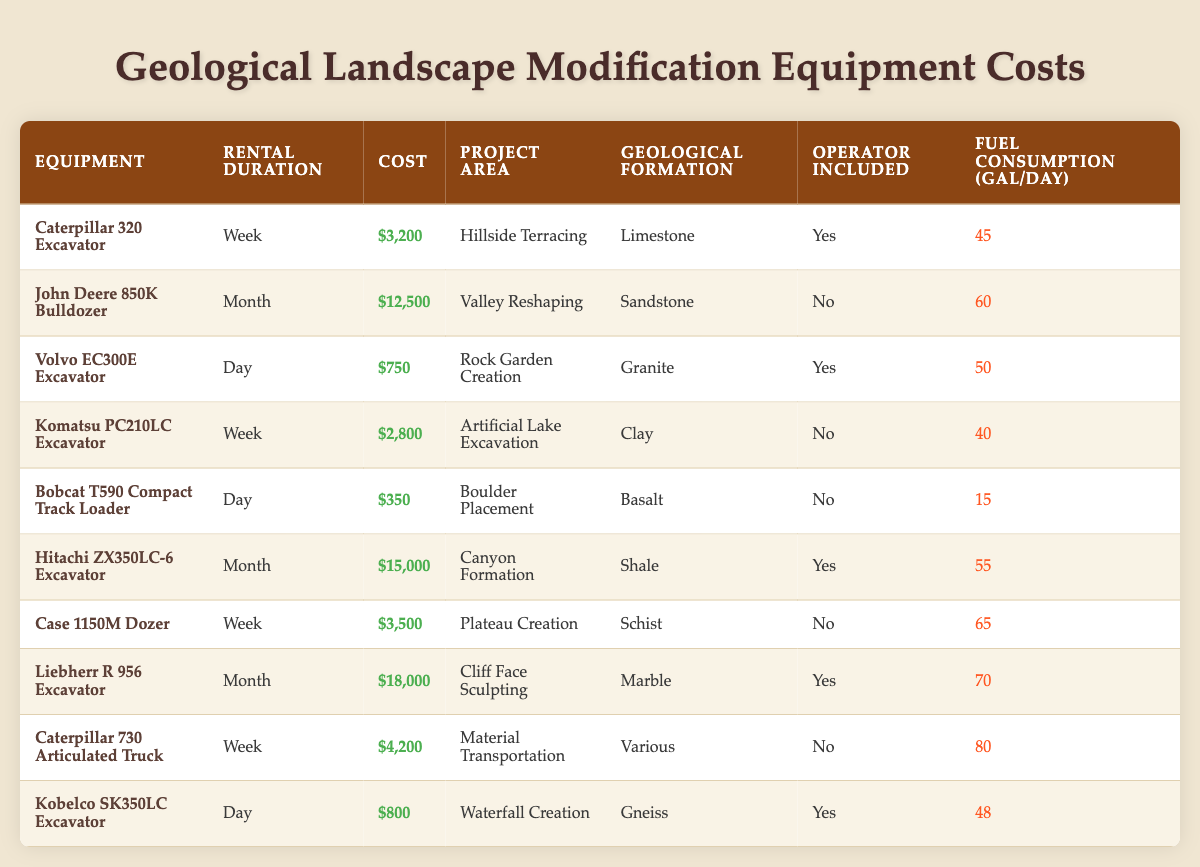What is the cost of renting the Caterpillar 320 Excavator for a week? The table lists the cost of the Caterpillar 320 Excavator under the "Cost" column, next to its rental duration of "Week." The value in that cell is $3,200.
Answer: $3,200 How many pieces of equipment require an operator? To determine this, I will check the "Operator Included" column for each piece of equipment. There are 5 entries with "Yes" in that column, indicating they require an operator.
Answer: 5 What is the total cost for renting the John Deere 850K Bulldozer for a month? The table provides the rental cost for the John Deere 850K Bulldozer listed under the "Cost" column for "Month," which is $12,500. As a single value, there's no need for complex calculations.
Answer: $12,500 Which equipment has the highest fuel consumption per day? Looking at the "Fuel Consumption (gal/day)" column, the highest value is 80 gallons for the Caterpillar 730 Articulated Truck, making it the equipment with the highest fuel consumption.
Answer: Caterpillar 730 Articulated Truck Calculate the average cost of all monthly rentals listed in the table. First, I need to identify the costs associated with the monthly rentals: $12,500 (John Deere 850K Bulldozer), $15,000 (Hitachi ZX350LC-6 Excavator), and $18,000 (Liebherr R 956 Excavator). I will add those costs: $12,500 + $15,000 + $18,000 = $45,500. There are three monthly rentals, so I divide the total by 3: $45,500 / 3 = $15,166.67.
Answer: $15,166.67 Is the Volvo EC300E Excavator rented by day, and does it include an operator? Referring to the table, the entry for the Volvo EC300E Excavator shows that it is rented by "Day" and has "Yes" listed under "Operator Included," so both statements are confirmed true.
Answer: Yes Which geological formation has the most equipment associated with it? By examining the "Geological Formation" column, I can see that there is one equipment each for Limestone, Sandstone, Granite, Clay, Basalt, Shale, Schist, Marble, Various, and Gneiss. There are no duplicates, so all geological formations have the same number of pieces of equipment associated with them, which is one.
Answer: None (all formations have one) What is the cost difference between the Liebherr R 956 Excavator and the Case 1150M Dozer? The cost of the Liebherr R 956 Excavator is $18,000, and the cost of the Case 1150M Dozer is $3,500. The difference is calculated by subtracting the latter from the former: $18,000 - $3,500 = $14,500.
Answer: $14,500 How many different geological formations are represented in the equipment list? By counting the unique entries in the "Geological Formation" column, I find that there are 10 distinct formations: Limestone, Sandstone, Granite, Clay, Basalt, Shale, Schist, Marble, Various, and Gneiss.
Answer: 10 